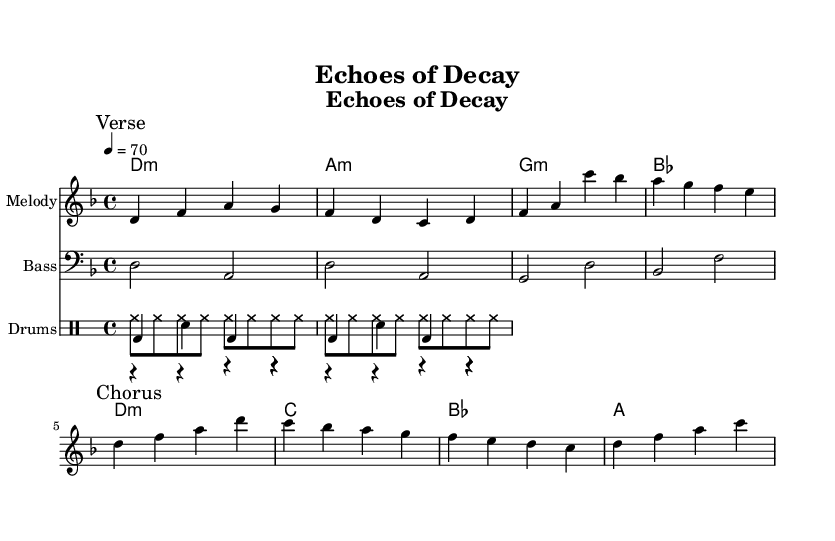What is the key signature of this music? The key signature listed in the global section indicates D minor, which contains one flat (B flat).
Answer: D minor What is the time signature of this music? The time signature found in the global section is 4/4, meaning there are four beats in each measure.
Answer: 4/4 What is the tempo marking of this piece? The tempo marking in the global section indicates a tempo of quarter note equals 70 beats per minute.
Answer: 70 How many measures are in the verse section? By counting the number of measures in the melody section marked "Verse," there are four measures present.
Answer: 4 What instrument is used for the melody? The instrument specified for the melody staff is "melodica," which is a keyboard instrument played by using a mouthpiece.
Answer: Melodica What dynamics could enhance the atmosphere of this reggae piece? Considering the themes of mortality and decay, using softer dynamics such as piano or pianissimo throughout could enhance the atmospheric quality.
Answer: Softer dynamics Which chord is played in the first measure of the verse? The first measure of the verse contains a D minor chord, denoted by "d1:m" in the chord names section.
Answer: D minor 